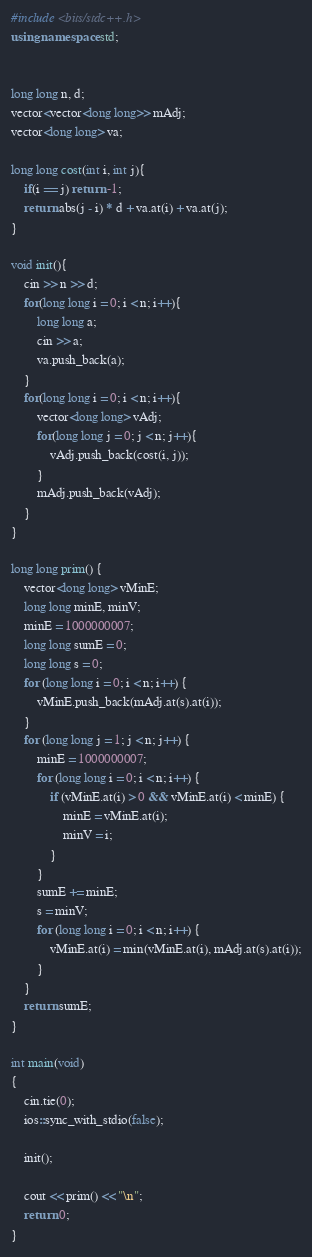Convert code to text. <code><loc_0><loc_0><loc_500><loc_500><_C++_>#include <bits/stdc++.h>
using namespace std;


long long n, d;
vector<vector<long long>> mAdj;
vector<long long> va;

long long cost(int i, int j){
    if(i == j) return -1;
    return abs(j - i) * d + va.at(i) + va.at(j);
}

void init(){
    cin >> n >> d;
    for(long long i = 0; i < n; i++){
        long long a;
        cin >> a;
        va.push_back(a);
    }
    for(long long i = 0; i < n; i++){
        vector<long long> vAdj;
        for(long long j = 0; j < n; j++){
            vAdj.push_back(cost(i, j));
        }
        mAdj.push_back(vAdj);
    }
}

long long prim() {
	vector<long long> vMinE;
	long long minE, minV;
	minE = 1000000007;
	long long sumE = 0;
	long long s = 0;
	for (long long i = 0; i < n; i++) {
		vMinE.push_back(mAdj.at(s).at(i));
	}
	for (long long j = 1; j < n; j++) {
		minE = 1000000007;
		for (long long i = 0; i < n; i++) {
			if (vMinE.at(i) > 0 && vMinE.at(i) < minE) {
				minE = vMinE.at(i);
				minV = i;
			}
		}
		sumE += minE;
		s = minV;
		for (long long i = 0; i < n; i++) {
			vMinE.at(i) = min(vMinE.at(i), mAdj.at(s).at(i));
		}
	}
	return sumE;
}

int main(void)
{
	cin.tie(0);
	ios::sync_with_stdio(false);

	init();

	cout << prim() << "\n";
	return 0;
}
</code> 